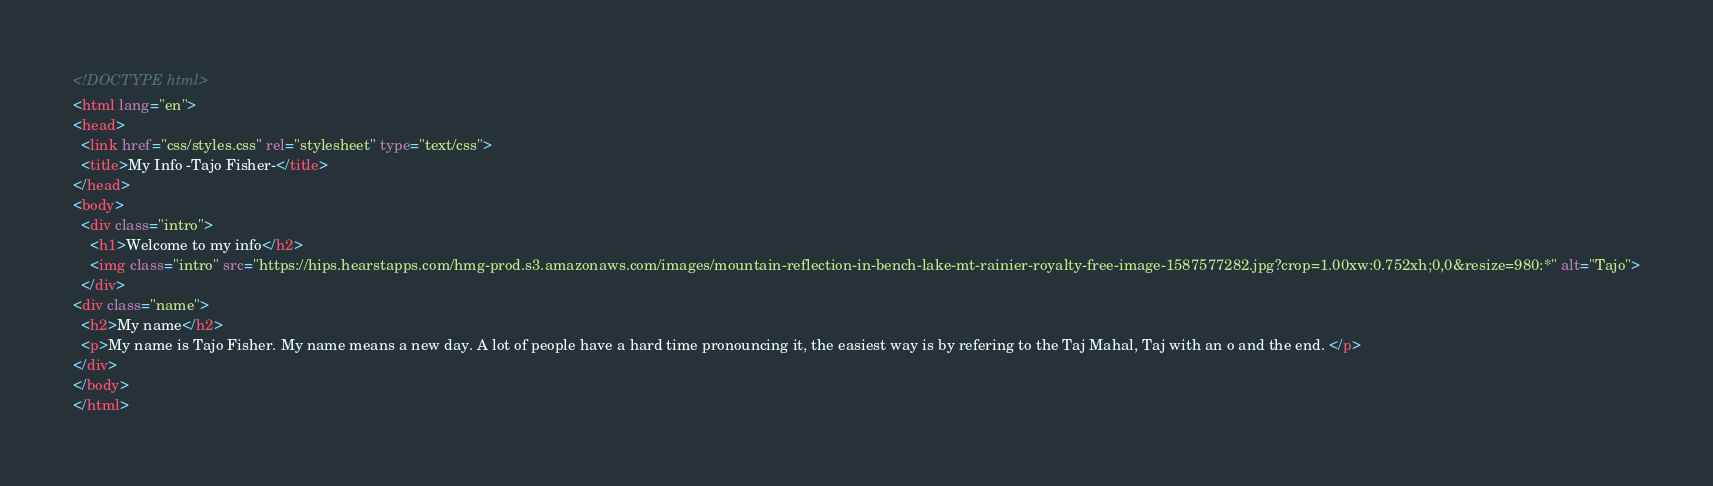<code> <loc_0><loc_0><loc_500><loc_500><_HTML_><!DOCTYPE html>
<html lang="en">
<head>
  <link href="css/styles.css" rel="stylesheet" type="text/css">
  <title>My Info -Tajo Fisher-</title>
</head>
<body>
  <div class="intro">
    <h1>Welcome to my info</h2>
    <img class="intro" src="https://hips.hearstapps.com/hmg-prod.s3.amazonaws.com/images/mountain-reflection-in-bench-lake-mt-rainier-royalty-free-image-1587577282.jpg?crop=1.00xw:0.752xh;0,0&resize=980:*" alt="Tajo">
  </div>
<div class="name">
  <h2>My name</h2>
  <p>My name is Tajo Fisher. My name means a new day. A lot of people have a hard time pronouncing it, the easiest way is by refering to the Taj Mahal, Taj with an o and the end. </p>
</div>
</body>
</html></code> 